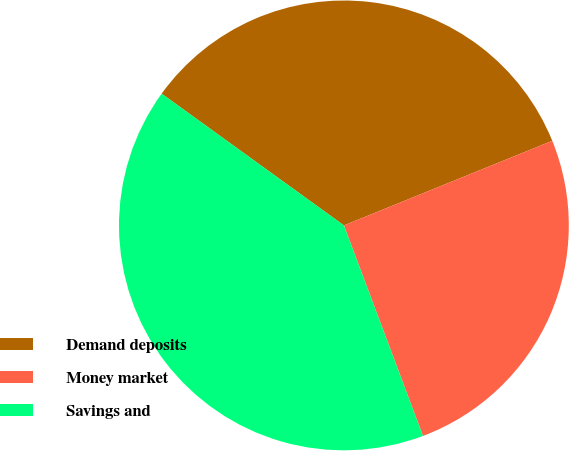<chart> <loc_0><loc_0><loc_500><loc_500><pie_chart><fcel>Demand deposits<fcel>Money market<fcel>Savings and<nl><fcel>33.9%<fcel>25.42%<fcel>40.68%<nl></chart> 